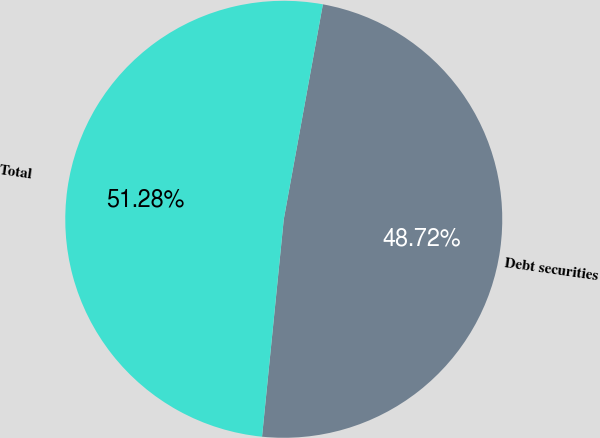Convert chart. <chart><loc_0><loc_0><loc_500><loc_500><pie_chart><fcel>Debt securities<fcel>Total<nl><fcel>48.72%<fcel>51.28%<nl></chart> 